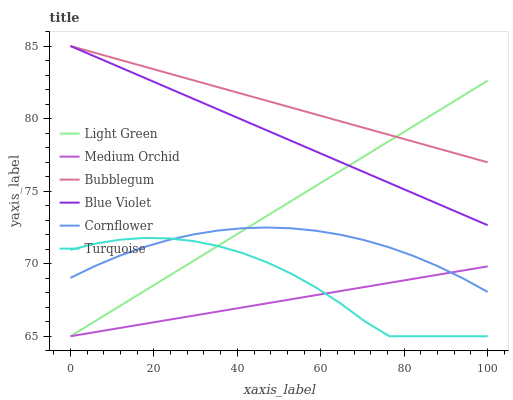Does Medium Orchid have the minimum area under the curve?
Answer yes or no. Yes. Does Bubblegum have the maximum area under the curve?
Answer yes or no. Yes. Does Turquoise have the minimum area under the curve?
Answer yes or no. No. Does Turquoise have the maximum area under the curve?
Answer yes or no. No. Is Light Green the smoothest?
Answer yes or no. Yes. Is Turquoise the roughest?
Answer yes or no. Yes. Is Medium Orchid the smoothest?
Answer yes or no. No. Is Medium Orchid the roughest?
Answer yes or no. No. Does Turquoise have the lowest value?
Answer yes or no. Yes. Does Bubblegum have the lowest value?
Answer yes or no. No. Does Blue Violet have the highest value?
Answer yes or no. Yes. Does Turquoise have the highest value?
Answer yes or no. No. Is Turquoise less than Blue Violet?
Answer yes or no. Yes. Is Bubblegum greater than Turquoise?
Answer yes or no. Yes. Does Cornflower intersect Medium Orchid?
Answer yes or no. Yes. Is Cornflower less than Medium Orchid?
Answer yes or no. No. Is Cornflower greater than Medium Orchid?
Answer yes or no. No. Does Turquoise intersect Blue Violet?
Answer yes or no. No. 